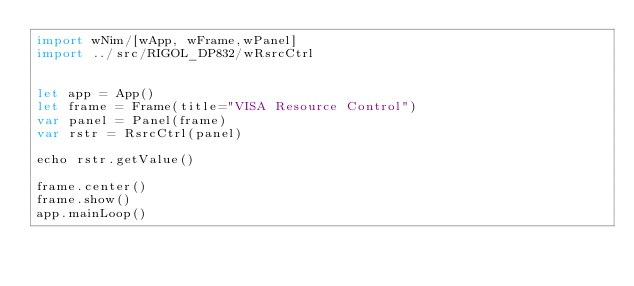<code> <loc_0><loc_0><loc_500><loc_500><_Nim_>import wNim/[wApp, wFrame,wPanel]
import ../src/RIGOL_DP832/wRsrcCtrl


let app = App()
let frame = Frame(title="VISA Resource Control")
var panel = Panel(frame)
var rstr = RsrcCtrl(panel)

echo rstr.getValue()

frame.center()
frame.show()
app.mainLoop()
</code> 